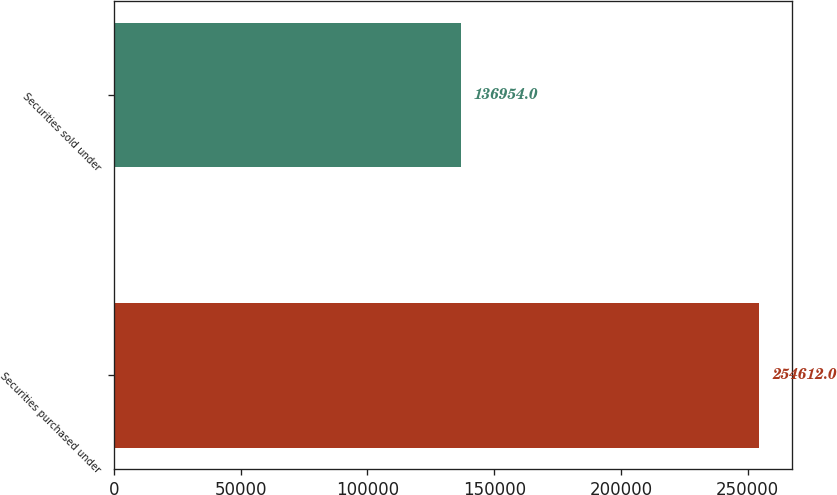<chart> <loc_0><loc_0><loc_500><loc_500><bar_chart><fcel>Securities purchased under<fcel>Securities sold under<nl><fcel>254612<fcel>136954<nl></chart> 